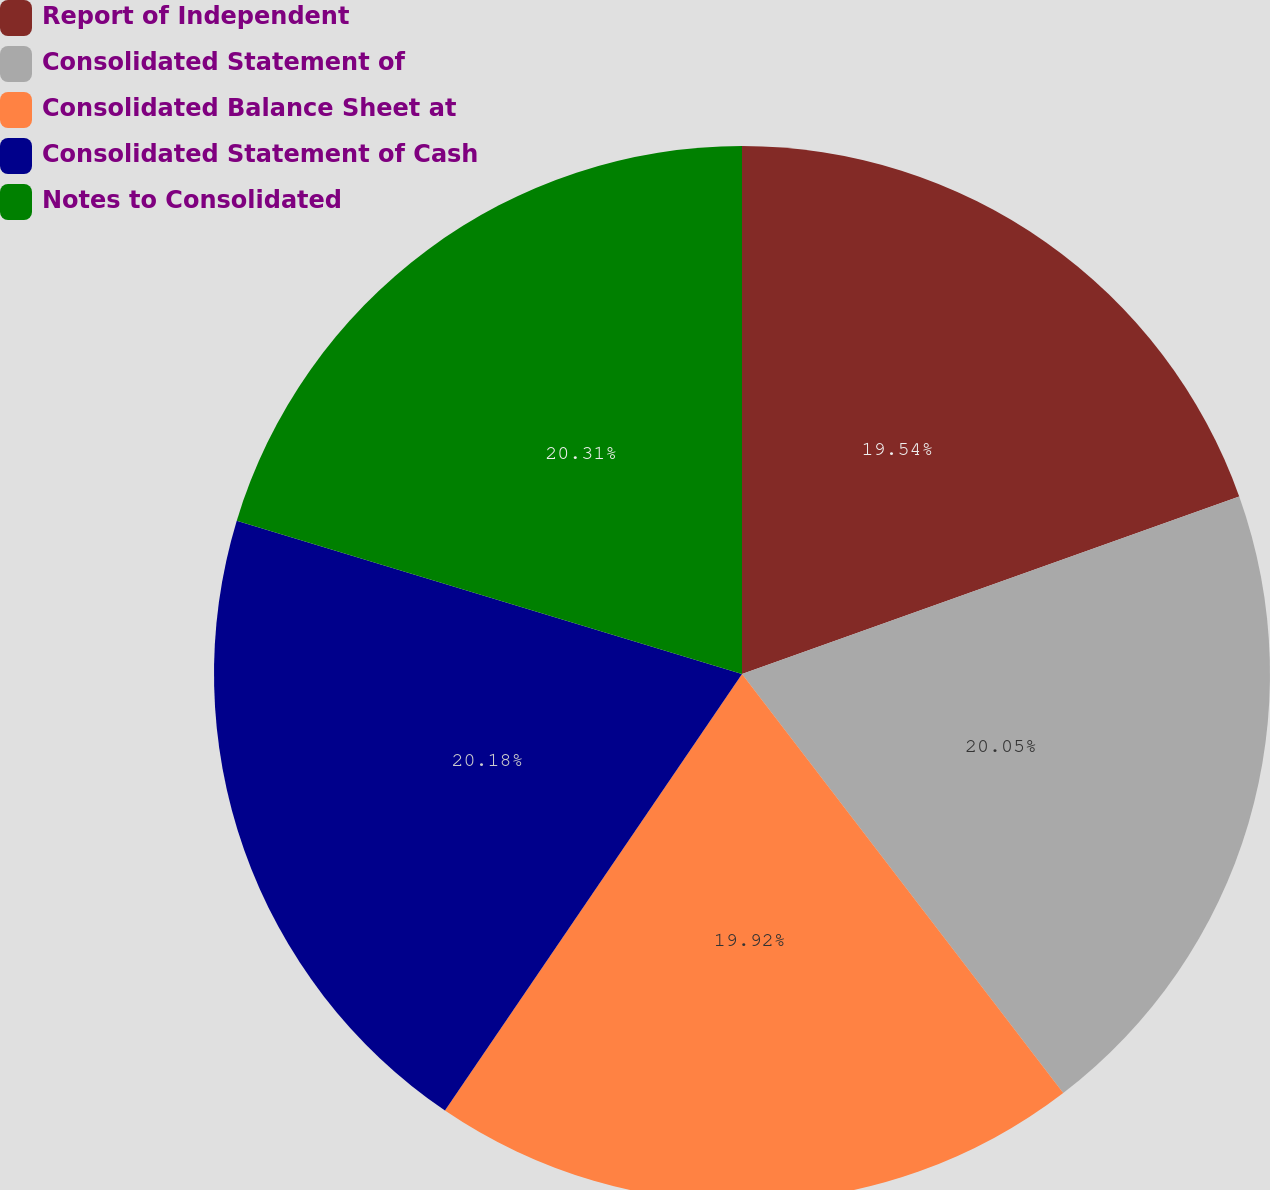<chart> <loc_0><loc_0><loc_500><loc_500><pie_chart><fcel>Report of Independent<fcel>Consolidated Statement of<fcel>Consolidated Balance Sheet at<fcel>Consolidated Statement of Cash<fcel>Notes to Consolidated<nl><fcel>19.54%<fcel>20.05%<fcel>19.92%<fcel>20.18%<fcel>20.31%<nl></chart> 